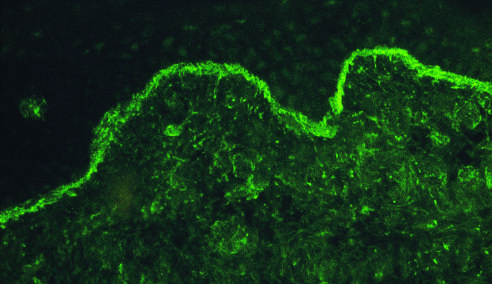what does an immunofluorescence micrograph stained for igg reveal?
Answer the question using a single word or phrase. Deposits of ig along the dermo-epidermal junction 